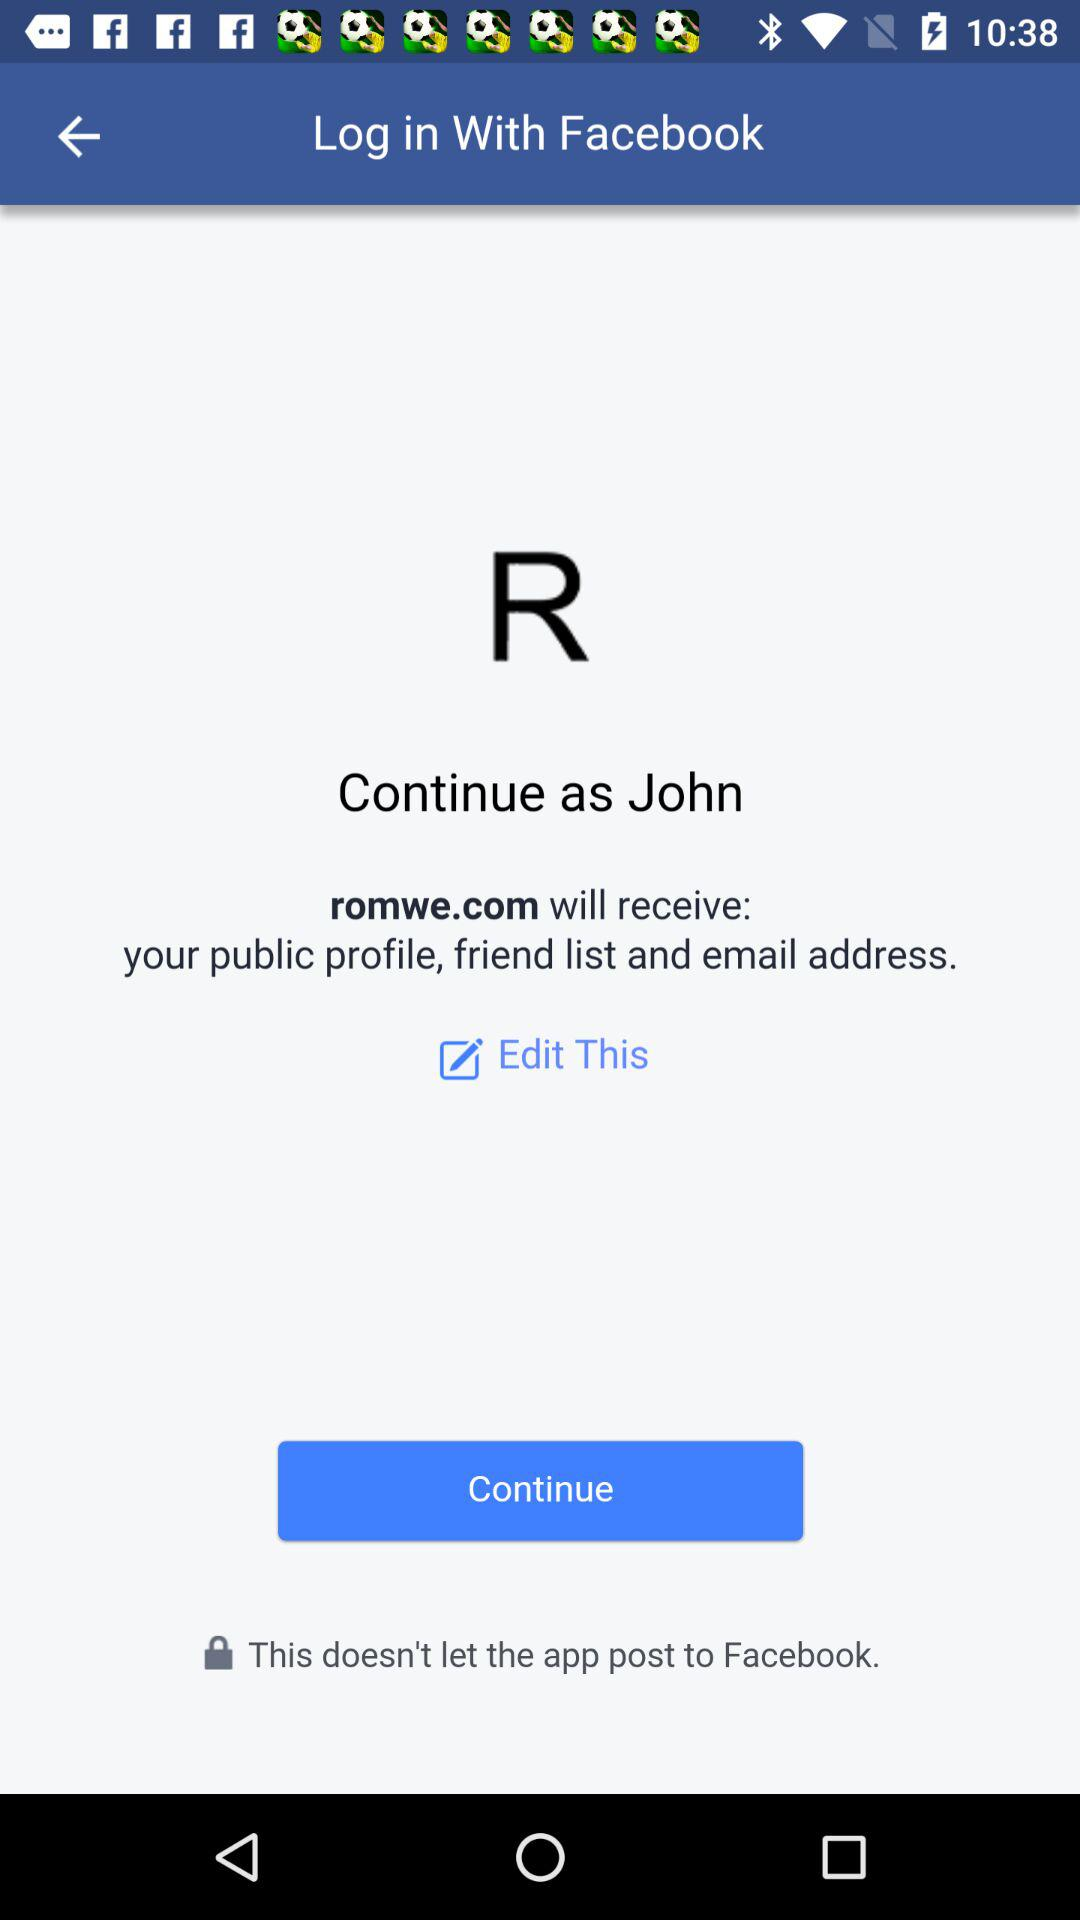Who will receive public profile? Public profile will be received by romwe.com. 